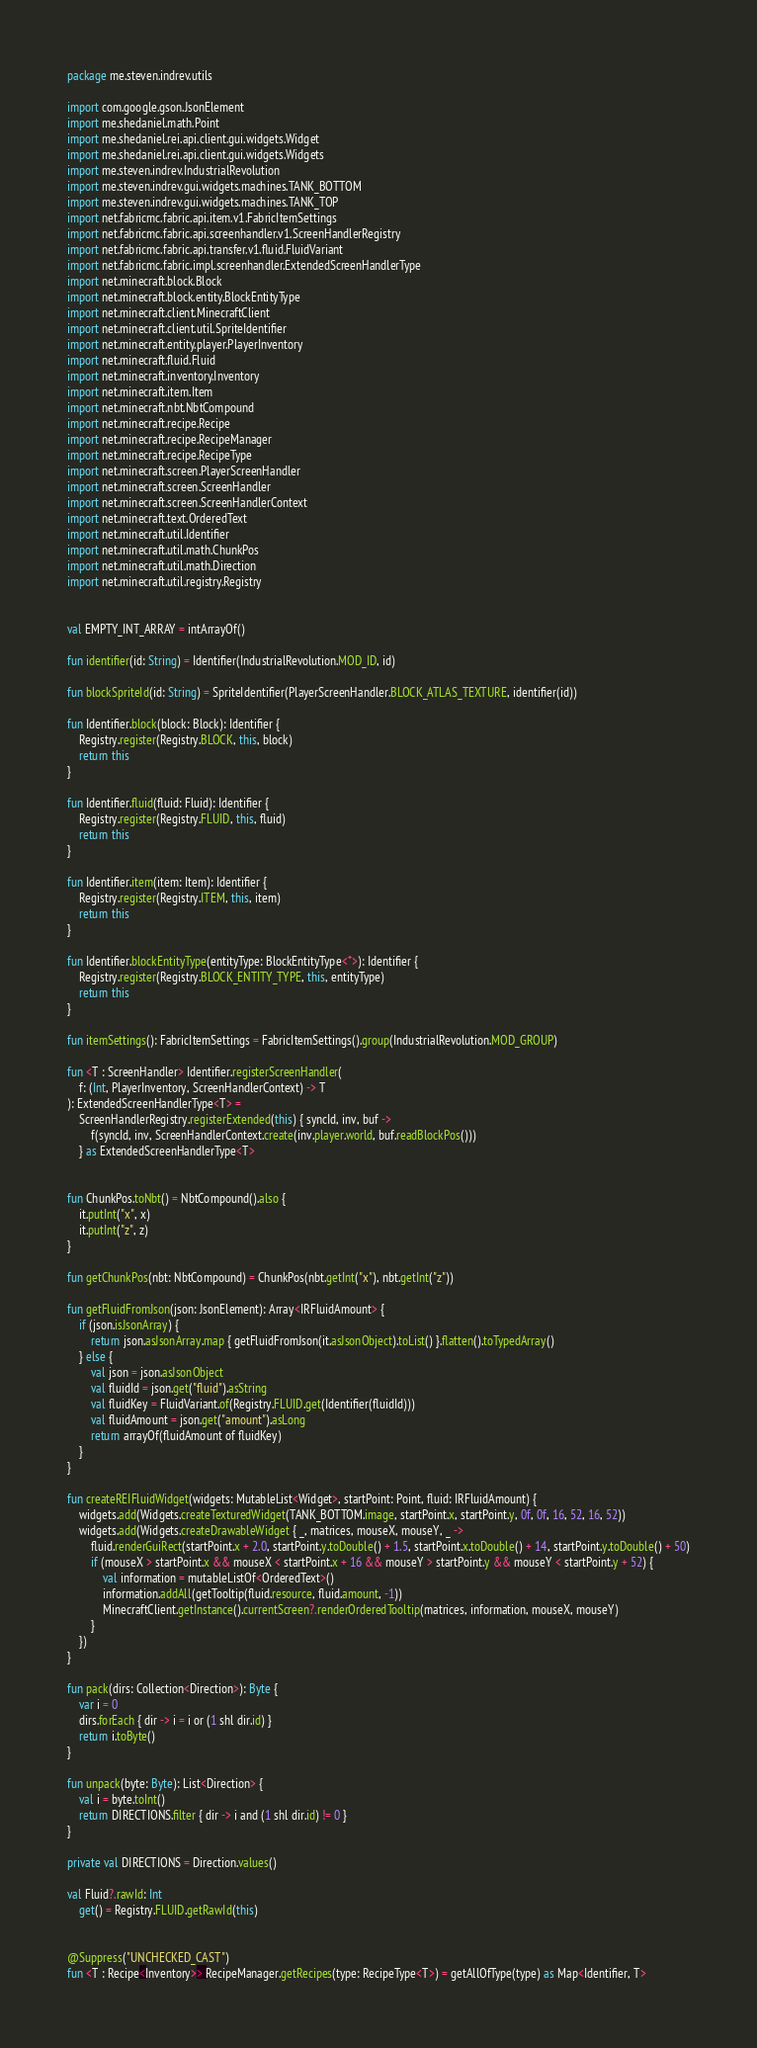Convert code to text. <code><loc_0><loc_0><loc_500><loc_500><_Kotlin_>package me.steven.indrev.utils

import com.google.gson.JsonElement
import me.shedaniel.math.Point
import me.shedaniel.rei.api.client.gui.widgets.Widget
import me.shedaniel.rei.api.client.gui.widgets.Widgets
import me.steven.indrev.IndustrialRevolution
import me.steven.indrev.gui.widgets.machines.TANK_BOTTOM
import me.steven.indrev.gui.widgets.machines.TANK_TOP
import net.fabricmc.fabric.api.item.v1.FabricItemSettings
import net.fabricmc.fabric.api.screenhandler.v1.ScreenHandlerRegistry
import net.fabricmc.fabric.api.transfer.v1.fluid.FluidVariant
import net.fabricmc.fabric.impl.screenhandler.ExtendedScreenHandlerType
import net.minecraft.block.Block
import net.minecraft.block.entity.BlockEntityType
import net.minecraft.client.MinecraftClient
import net.minecraft.client.util.SpriteIdentifier
import net.minecraft.entity.player.PlayerInventory
import net.minecraft.fluid.Fluid
import net.minecraft.inventory.Inventory
import net.minecraft.item.Item
import net.minecraft.nbt.NbtCompound
import net.minecraft.recipe.Recipe
import net.minecraft.recipe.RecipeManager
import net.minecraft.recipe.RecipeType
import net.minecraft.screen.PlayerScreenHandler
import net.minecraft.screen.ScreenHandler
import net.minecraft.screen.ScreenHandlerContext
import net.minecraft.text.OrderedText
import net.minecraft.util.Identifier
import net.minecraft.util.math.ChunkPos
import net.minecraft.util.math.Direction
import net.minecraft.util.registry.Registry


val EMPTY_INT_ARRAY = intArrayOf()

fun identifier(id: String) = Identifier(IndustrialRevolution.MOD_ID, id)

fun blockSpriteId(id: String) = SpriteIdentifier(PlayerScreenHandler.BLOCK_ATLAS_TEXTURE, identifier(id))

fun Identifier.block(block: Block): Identifier {
    Registry.register(Registry.BLOCK, this, block)
    return this
}

fun Identifier.fluid(fluid: Fluid): Identifier {
    Registry.register(Registry.FLUID, this, fluid)
    return this
}

fun Identifier.item(item: Item): Identifier {
    Registry.register(Registry.ITEM, this, item)
    return this
}

fun Identifier.blockEntityType(entityType: BlockEntityType<*>): Identifier {
    Registry.register(Registry.BLOCK_ENTITY_TYPE, this, entityType)
    return this
}

fun itemSettings(): FabricItemSettings = FabricItemSettings().group(IndustrialRevolution.MOD_GROUP)

fun <T : ScreenHandler> Identifier.registerScreenHandler(
    f: (Int, PlayerInventory, ScreenHandlerContext) -> T
): ExtendedScreenHandlerType<T> =
    ScreenHandlerRegistry.registerExtended(this) { syncId, inv, buf ->
        f(syncId, inv, ScreenHandlerContext.create(inv.player.world, buf.readBlockPos()))
    } as ExtendedScreenHandlerType<T>


fun ChunkPos.toNbt() = NbtCompound().also {
    it.putInt("x", x)
    it.putInt("z", z)
}

fun getChunkPos(nbt: NbtCompound) = ChunkPos(nbt.getInt("x"), nbt.getInt("z"))

fun getFluidFromJson(json: JsonElement): Array<IRFluidAmount> {
    if (json.isJsonArray) {
        return json.asJsonArray.map { getFluidFromJson(it.asJsonObject).toList() }.flatten().toTypedArray()
    } else {
        val json = json.asJsonObject
        val fluidId = json.get("fluid").asString
        val fluidKey = FluidVariant.of(Registry.FLUID.get(Identifier(fluidId)))
        val fluidAmount = json.get("amount").asLong
        return arrayOf(fluidAmount of fluidKey)
    }
}

fun createREIFluidWidget(widgets: MutableList<Widget>, startPoint: Point, fluid: IRFluidAmount) {
    widgets.add(Widgets.createTexturedWidget(TANK_BOTTOM.image, startPoint.x, startPoint.y, 0f, 0f, 16, 52, 16, 52))
    widgets.add(Widgets.createDrawableWidget { _, matrices, mouseX, mouseY, _ ->
        fluid.renderGuiRect(startPoint.x + 2.0, startPoint.y.toDouble() + 1.5, startPoint.x.toDouble() + 14, startPoint.y.toDouble() + 50)
        if (mouseX > startPoint.x && mouseX < startPoint.x + 16 && mouseY > startPoint.y && mouseY < startPoint.y + 52) {
            val information = mutableListOf<OrderedText>()
            information.addAll(getTooltip(fluid.resource, fluid.amount, -1))
            MinecraftClient.getInstance().currentScreen?.renderOrderedTooltip(matrices, information, mouseX, mouseY)
        }
    })
}

fun pack(dirs: Collection<Direction>): Byte {
    var i = 0
    dirs.forEach { dir -> i = i or (1 shl dir.id) }
    return i.toByte()
}

fun unpack(byte: Byte): List<Direction> {
    val i = byte.toInt()
    return DIRECTIONS.filter { dir -> i and (1 shl dir.id) != 0 }
}

private val DIRECTIONS = Direction.values()

val Fluid?.rawId: Int
    get() = Registry.FLUID.getRawId(this)


@Suppress("UNCHECKED_CAST")
fun <T : Recipe<Inventory>> RecipeManager.getRecipes(type: RecipeType<T>) = getAllOfType(type) as Map<Identifier, T></code> 